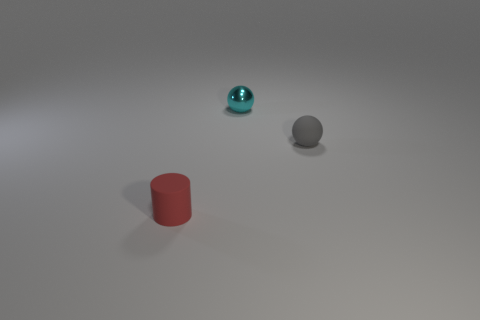Is there any other thing that is the same material as the small cyan sphere?
Keep it short and to the point. No. Are there any red things made of the same material as the tiny red cylinder?
Offer a terse response. No. There is a cyan ball that is the same size as the red rubber object; what material is it?
Offer a very short reply. Metal. Are there fewer small things behind the gray rubber thing than tiny red things that are on the right side of the tiny cyan shiny sphere?
Your answer should be compact. No. There is a tiny thing that is behind the red matte thing and in front of the small cyan sphere; what is its shape?
Your answer should be compact. Sphere. What number of large metal objects are the same shape as the tiny cyan thing?
Give a very brief answer. 0. The gray thing that is made of the same material as the tiny red cylinder is what size?
Your answer should be very brief. Small. Is the number of green metallic cubes greater than the number of tiny gray matte things?
Your answer should be very brief. No. What color is the small matte object to the left of the metallic object?
Provide a succinct answer. Red. There is a object that is behind the red cylinder and left of the gray rubber sphere; what size is it?
Ensure brevity in your answer.  Small. 